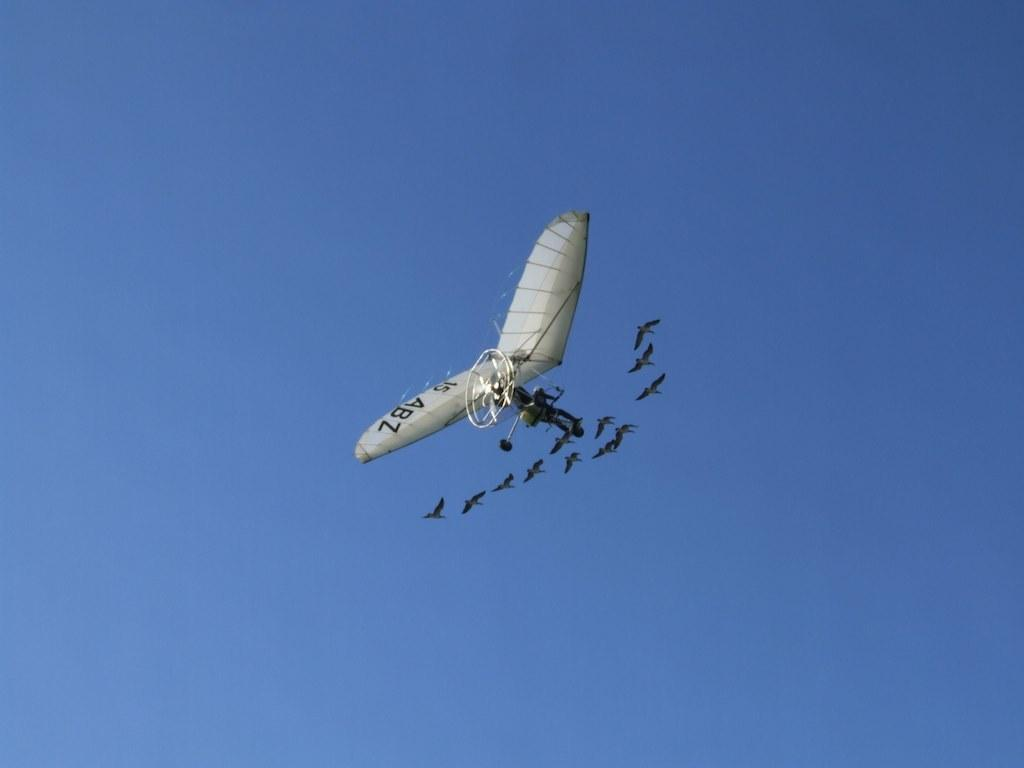<image>
Offer a succinct explanation of the picture presented. A person flies a glider with 15 ABZ on its wings as a flock of birds follows closely behind him. 